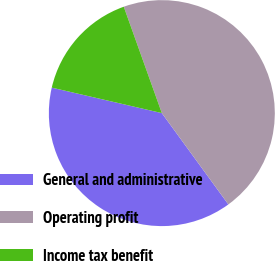Convert chart. <chart><loc_0><loc_0><loc_500><loc_500><pie_chart><fcel>General and administrative<fcel>Operating profit<fcel>Income tax benefit<nl><fcel>38.64%<fcel>45.45%<fcel>15.91%<nl></chart> 